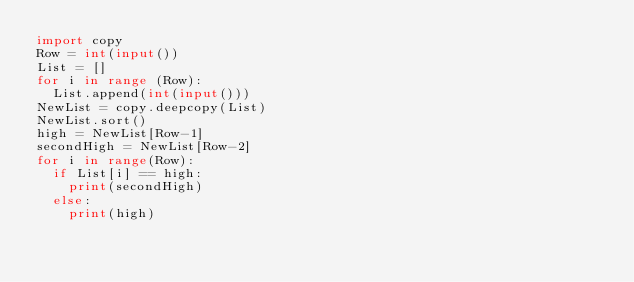<code> <loc_0><loc_0><loc_500><loc_500><_Python_>import copy
Row = int(input())
List = []
for i in range (Row):
  List.append(int(input()))
NewList = copy.deepcopy(List)
NewList.sort()
high = NewList[Row-1]
secondHigh = NewList[Row-2]
for i in range(Row):
  if List[i] == high:
    print(secondHigh)
  else:
    print(high)
  </code> 